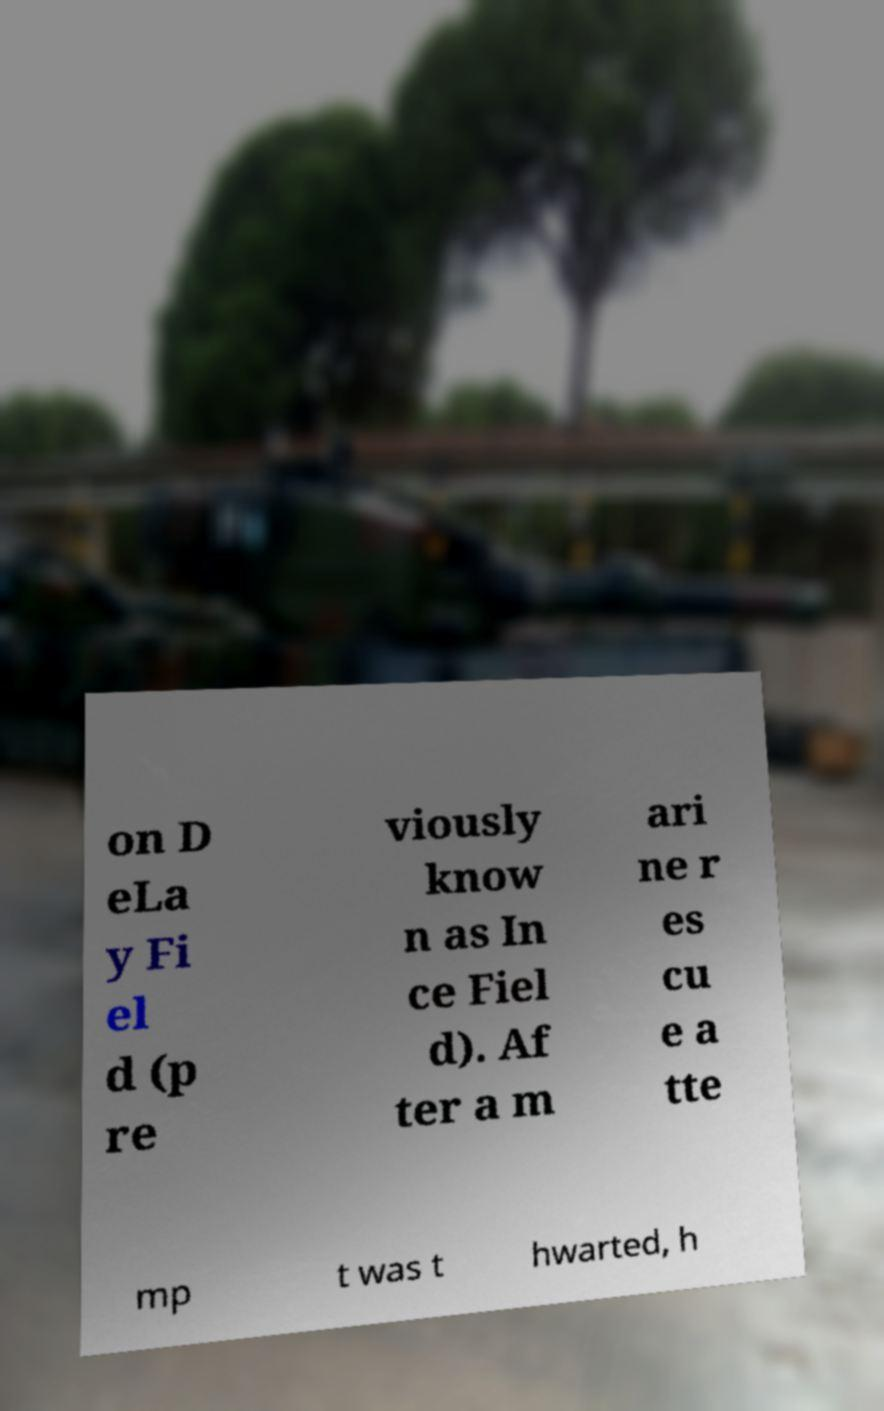Please identify and transcribe the text found in this image. on D eLa y Fi el d (p re viously know n as In ce Fiel d). Af ter a m ari ne r es cu e a tte mp t was t hwarted, h 